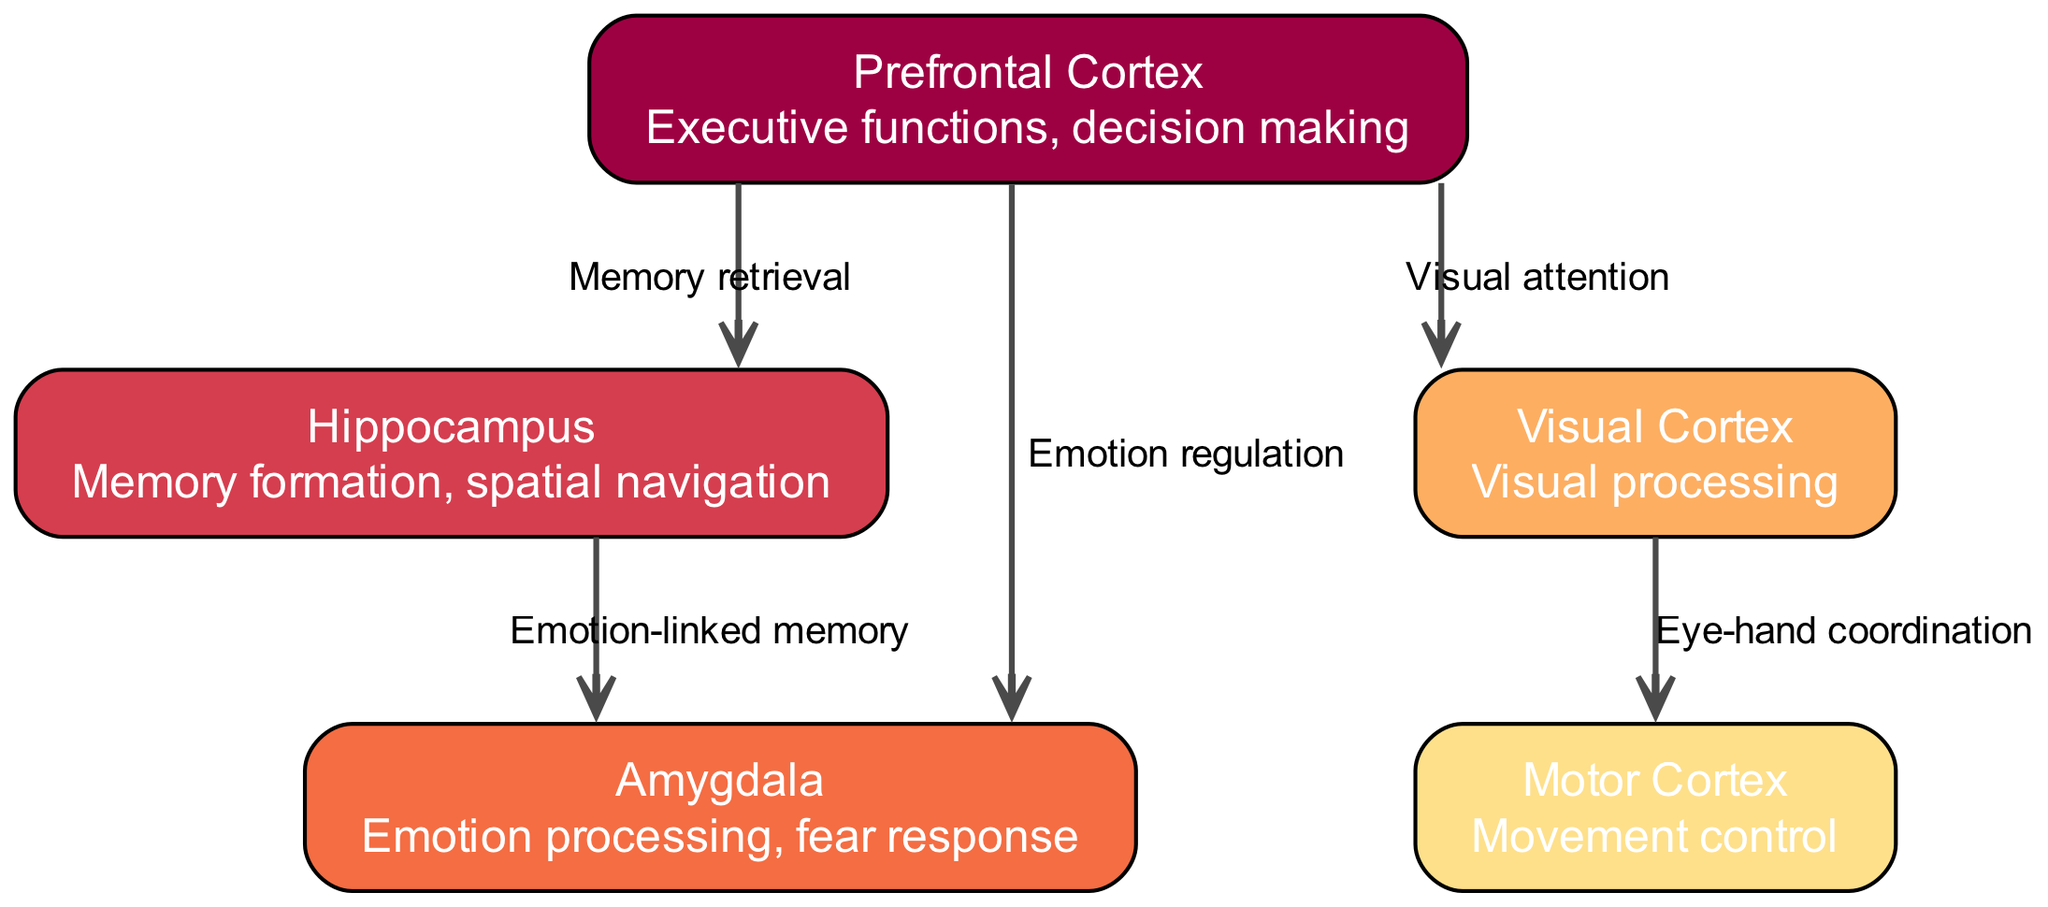What are the names of the nodes in the diagram? The diagram contains the following nodes: Prefrontal Cortex, Hippocampus, Amygdala, Visual Cortex, Motor Cortex.
Answer: Prefrontal Cortex, Hippocampus, Amygdala, Visual Cortex, Motor Cortex How many nodes are present in the diagram? The diagram features five distinct nodes.
Answer: 5 Which node is responsible for memory formation? The node specifically associated with memory formation is the Hippocampus.
Answer: Hippocampus How many edges are connecting the Prefrontal Cortex? The Prefrontal Cortex is connected by three edges to other nodes.
Answer: 3 What is the relationship between the Prefrontal Cortex and the Visual Cortex? The edge between the Prefrontal Cortex and the Visual Cortex describes the function of visual attention.
Answer: Visual attention Which two nodes are connected by the emotion-linked memory edge? The edge for emotion-linked memory connects the Hippocampus and the Amygdala.
Answer: Hippocampus and Amygdala What specific function links the Visual Cortex and Motor Cortex? The edge indicates a relationship defined as eye-hand coordination between the Visual Cortex and Motor Cortex.
Answer: Eye-hand coordination Which node has the function of executive functions and decision making? The Prefrontal Cortex is designated with the responsibility of executive functions and decision making.
Answer: Prefrontal Cortex How many types of functions are represented by the edges in the diagram? There are five distinct functions represented by the edges, each illustrating a different relationship between the nodes.
Answer: 5 